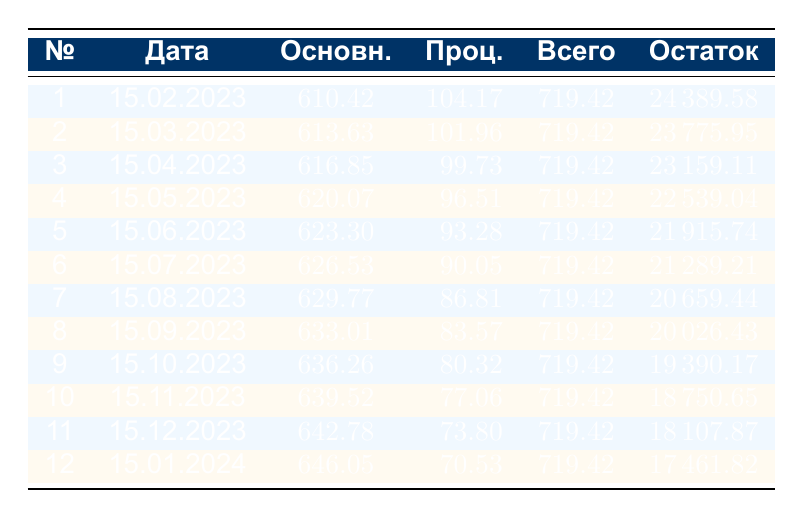What is the total payment for the first installment? The first payment, as shown in the table, is listed under the "Всего" column for payment number 1. The value is 719.42.
Answer: 719.42 What is the principal payment for the eighth installment? The principal payment can be found in the "Основн." column for payment number 8. The value is 633.01.
Answer: 633.01 What is the total interest payment for the first six installments? To calculate the total interest for the first six installments, add the values in the "Проц." column for payments 1 through 6: 104.17 + 101.96 + 99.73 + 96.51 + 93.28 + 90.05 = 585.70.
Answer: 585.70 Is the total payment for the fifth installment greater than the total payment for the fourth installment? Comparing the "Всего" column values: both payments are 719.42. Since they are equal, the answer is no.
Answer: No What is the remaining balance after the twelfth installment? The remaining balance after the twelfth payment is located in the "Остаток" column for payment number 12. This value is 17461.82.
Answer: 17461.82 Which installment has the highest principal payment and what is that amount? Reviewing the principal payments in the "Основн." column, the twelfth installment payment is the highest at 646.05.
Answer: 646.05 How much has the remaining balance decreased after the first three payments? The remaining balance after the first payment is 24389.58 and after the third payment is 23159.11. The decrease is 24389.58 - 23159.11 = 230.47.
Answer: 230.47 Is the interest payment for the seventh installment less than the principal payment for the sixth installment? The interest payment for the seventh installment is 86.81 (from the "Проц." column) and the principal payment for the sixth installment is 626.53. Since 86.81 is less than 626.53, the answer is yes.
Answer: Yes What is the average remaining balance at the end of the first six installments? The remaining balances for the first six installments are: 24389.58, 23775.95, 23159.11, 22539.04, 21915.74, and 21289.21. To find the average, sum these values: 24389.58 + 23775.95 + 23159.11 + 22539.04 + 21915.74 + 21289.21 = 136968.63 and divide by 6, which gives an average of 22828.11.
Answer: 22828.11 